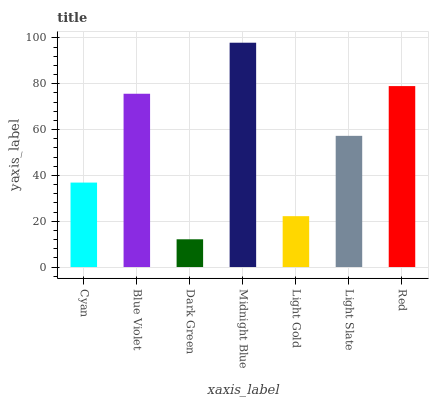Is Blue Violet the minimum?
Answer yes or no. No. Is Blue Violet the maximum?
Answer yes or no. No. Is Blue Violet greater than Cyan?
Answer yes or no. Yes. Is Cyan less than Blue Violet?
Answer yes or no. Yes. Is Cyan greater than Blue Violet?
Answer yes or no. No. Is Blue Violet less than Cyan?
Answer yes or no. No. Is Light Slate the high median?
Answer yes or no. Yes. Is Light Slate the low median?
Answer yes or no. Yes. Is Red the high median?
Answer yes or no. No. Is Cyan the low median?
Answer yes or no. No. 